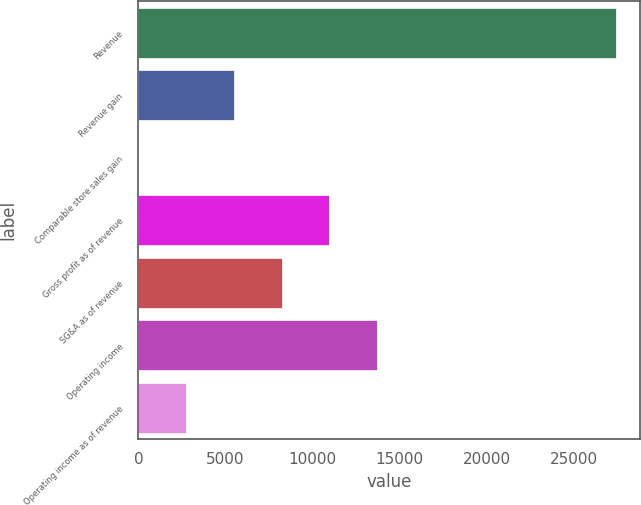Convert chart to OTSL. <chart><loc_0><loc_0><loc_500><loc_500><bar_chart><fcel>Revenue<fcel>Revenue gain<fcel>Comparable store sales gain<fcel>Gross profit as of revenue<fcel>SG&A as of revenue<fcel>Operating income<fcel>Operating income as of revenue<nl><fcel>27380<fcel>5480.08<fcel>5.1<fcel>10955.1<fcel>8217.57<fcel>13692.5<fcel>2742.59<nl></chart> 